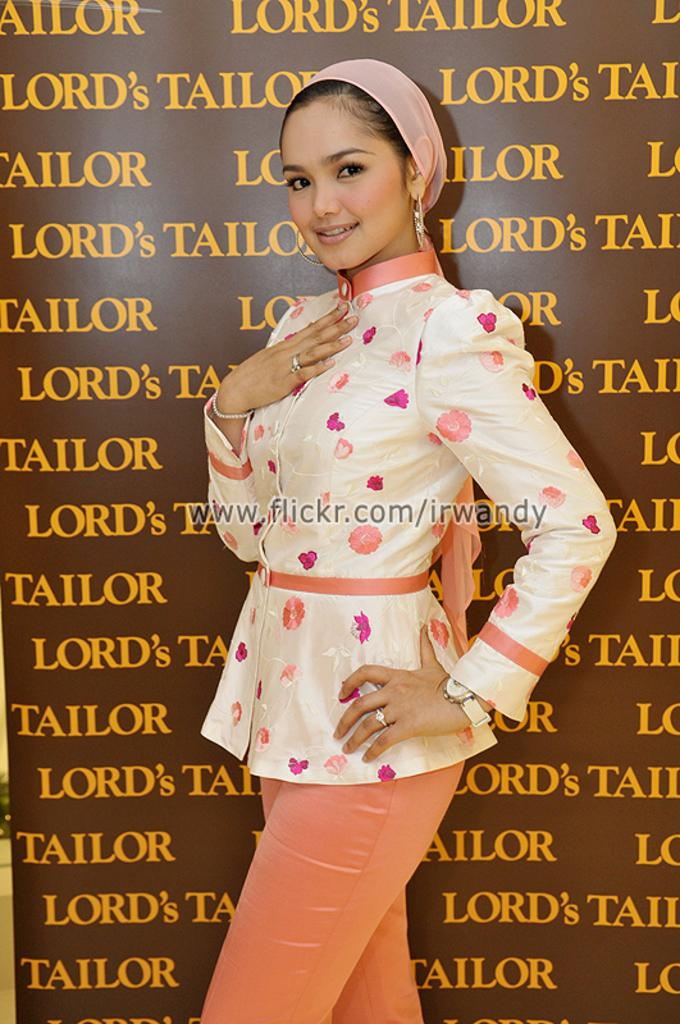Who is the main subject in the image? There is a girl in the image. What is the girl standing in front of? The girl is standing in front of a banner. What might the girl be doing in the image? The girl appears to be a model. What is on the girl's head in the image? The girl has a band over her head. What accessory is the girl wearing on her hand? The girl is wearing a watch on her hand. What is the smell of the men in the image? There are no men present in the image, so it is not possible to determine their smell. 